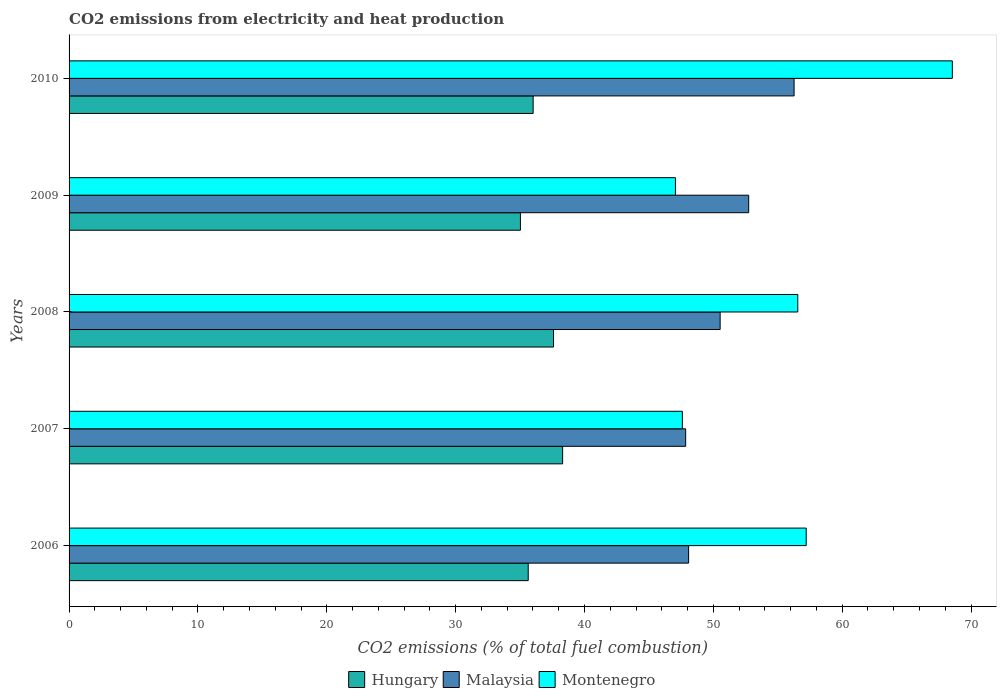How many different coloured bars are there?
Make the answer very short. 3. How many groups of bars are there?
Make the answer very short. 5. In how many cases, is the number of bars for a given year not equal to the number of legend labels?
Give a very brief answer. 0. What is the amount of CO2 emitted in Malaysia in 2010?
Ensure brevity in your answer.  56.27. Across all years, what is the maximum amount of CO2 emitted in Hungary?
Make the answer very short. 38.3. Across all years, what is the minimum amount of CO2 emitted in Hungary?
Your answer should be compact. 35.03. What is the total amount of CO2 emitted in Malaysia in the graph?
Your answer should be very brief. 255.48. What is the difference between the amount of CO2 emitted in Malaysia in 2006 and that in 2007?
Your answer should be very brief. 0.23. What is the difference between the amount of CO2 emitted in Malaysia in 2010 and the amount of CO2 emitted in Hungary in 2009?
Provide a succinct answer. 21.24. What is the average amount of CO2 emitted in Montenegro per year?
Provide a succinct answer. 55.39. In the year 2009, what is the difference between the amount of CO2 emitted in Montenegro and amount of CO2 emitted in Malaysia?
Offer a terse response. -5.69. In how many years, is the amount of CO2 emitted in Malaysia greater than 66 %?
Give a very brief answer. 0. What is the ratio of the amount of CO2 emitted in Malaysia in 2009 to that in 2010?
Your answer should be very brief. 0.94. Is the amount of CO2 emitted in Malaysia in 2008 less than that in 2010?
Make the answer very short. Yes. What is the difference between the highest and the second highest amount of CO2 emitted in Montenegro?
Ensure brevity in your answer.  11.34. What is the difference between the highest and the lowest amount of CO2 emitted in Montenegro?
Your answer should be compact. 21.49. In how many years, is the amount of CO2 emitted in Hungary greater than the average amount of CO2 emitted in Hungary taken over all years?
Your answer should be compact. 2. Is the sum of the amount of CO2 emitted in Montenegro in 2006 and 2008 greater than the maximum amount of CO2 emitted in Malaysia across all years?
Provide a short and direct response. Yes. What does the 2nd bar from the top in 2010 represents?
Make the answer very short. Malaysia. What does the 2nd bar from the bottom in 2008 represents?
Offer a terse response. Malaysia. How many bars are there?
Make the answer very short. 15. Are all the bars in the graph horizontal?
Your answer should be very brief. Yes. What is the difference between two consecutive major ticks on the X-axis?
Your answer should be very brief. 10. How are the legend labels stacked?
Your answer should be very brief. Horizontal. What is the title of the graph?
Your answer should be compact. CO2 emissions from electricity and heat production. What is the label or title of the X-axis?
Your answer should be very brief. CO2 emissions (% of total fuel combustion). What is the CO2 emissions (% of total fuel combustion) in Hungary in 2006?
Offer a terse response. 35.63. What is the CO2 emissions (% of total fuel combustion) in Malaysia in 2006?
Offer a very short reply. 48.08. What is the CO2 emissions (% of total fuel combustion) of Montenegro in 2006?
Offer a terse response. 57.21. What is the CO2 emissions (% of total fuel combustion) in Hungary in 2007?
Keep it short and to the point. 38.3. What is the CO2 emissions (% of total fuel combustion) in Malaysia in 2007?
Your response must be concise. 47.85. What is the CO2 emissions (% of total fuel combustion) in Montenegro in 2007?
Your response must be concise. 47.6. What is the CO2 emissions (% of total fuel combustion) in Hungary in 2008?
Keep it short and to the point. 37.6. What is the CO2 emissions (% of total fuel combustion) in Malaysia in 2008?
Ensure brevity in your answer.  50.53. What is the CO2 emissions (% of total fuel combustion) of Montenegro in 2008?
Give a very brief answer. 56.55. What is the CO2 emissions (% of total fuel combustion) of Hungary in 2009?
Make the answer very short. 35.03. What is the CO2 emissions (% of total fuel combustion) of Malaysia in 2009?
Make the answer very short. 52.75. What is the CO2 emissions (% of total fuel combustion) of Montenegro in 2009?
Give a very brief answer. 47.06. What is the CO2 emissions (% of total fuel combustion) of Hungary in 2010?
Provide a succinct answer. 36.02. What is the CO2 emissions (% of total fuel combustion) in Malaysia in 2010?
Provide a short and direct response. 56.27. What is the CO2 emissions (% of total fuel combustion) in Montenegro in 2010?
Offer a very short reply. 68.55. Across all years, what is the maximum CO2 emissions (% of total fuel combustion) of Hungary?
Keep it short and to the point. 38.3. Across all years, what is the maximum CO2 emissions (% of total fuel combustion) in Malaysia?
Provide a short and direct response. 56.27. Across all years, what is the maximum CO2 emissions (% of total fuel combustion) in Montenegro?
Give a very brief answer. 68.55. Across all years, what is the minimum CO2 emissions (% of total fuel combustion) in Hungary?
Your answer should be compact. 35.03. Across all years, what is the minimum CO2 emissions (% of total fuel combustion) in Malaysia?
Keep it short and to the point. 47.85. Across all years, what is the minimum CO2 emissions (% of total fuel combustion) of Montenegro?
Your answer should be compact. 47.06. What is the total CO2 emissions (% of total fuel combustion) in Hungary in the graph?
Provide a succinct answer. 182.58. What is the total CO2 emissions (% of total fuel combustion) in Malaysia in the graph?
Keep it short and to the point. 255.48. What is the total CO2 emissions (% of total fuel combustion) of Montenegro in the graph?
Offer a very short reply. 276.96. What is the difference between the CO2 emissions (% of total fuel combustion) in Hungary in 2006 and that in 2007?
Offer a terse response. -2.67. What is the difference between the CO2 emissions (% of total fuel combustion) of Malaysia in 2006 and that in 2007?
Ensure brevity in your answer.  0.23. What is the difference between the CO2 emissions (% of total fuel combustion) of Montenegro in 2006 and that in 2007?
Provide a succinct answer. 9.61. What is the difference between the CO2 emissions (% of total fuel combustion) of Hungary in 2006 and that in 2008?
Your response must be concise. -1.96. What is the difference between the CO2 emissions (% of total fuel combustion) of Malaysia in 2006 and that in 2008?
Provide a short and direct response. -2.45. What is the difference between the CO2 emissions (% of total fuel combustion) of Montenegro in 2006 and that in 2008?
Keep it short and to the point. 0.65. What is the difference between the CO2 emissions (% of total fuel combustion) in Hungary in 2006 and that in 2009?
Your response must be concise. 0.6. What is the difference between the CO2 emissions (% of total fuel combustion) in Malaysia in 2006 and that in 2009?
Your response must be concise. -4.66. What is the difference between the CO2 emissions (% of total fuel combustion) of Montenegro in 2006 and that in 2009?
Offer a terse response. 10.15. What is the difference between the CO2 emissions (% of total fuel combustion) in Hungary in 2006 and that in 2010?
Ensure brevity in your answer.  -0.38. What is the difference between the CO2 emissions (% of total fuel combustion) of Malaysia in 2006 and that in 2010?
Provide a succinct answer. -8.19. What is the difference between the CO2 emissions (% of total fuel combustion) in Montenegro in 2006 and that in 2010?
Keep it short and to the point. -11.34. What is the difference between the CO2 emissions (% of total fuel combustion) in Hungary in 2007 and that in 2008?
Provide a succinct answer. 0.71. What is the difference between the CO2 emissions (% of total fuel combustion) in Malaysia in 2007 and that in 2008?
Make the answer very short. -2.68. What is the difference between the CO2 emissions (% of total fuel combustion) in Montenegro in 2007 and that in 2008?
Provide a succinct answer. -8.96. What is the difference between the CO2 emissions (% of total fuel combustion) of Hungary in 2007 and that in 2009?
Provide a short and direct response. 3.27. What is the difference between the CO2 emissions (% of total fuel combustion) in Malaysia in 2007 and that in 2009?
Your answer should be compact. -4.89. What is the difference between the CO2 emissions (% of total fuel combustion) in Montenegro in 2007 and that in 2009?
Make the answer very short. 0.54. What is the difference between the CO2 emissions (% of total fuel combustion) of Hungary in 2007 and that in 2010?
Provide a succinct answer. 2.29. What is the difference between the CO2 emissions (% of total fuel combustion) in Malaysia in 2007 and that in 2010?
Offer a terse response. -8.42. What is the difference between the CO2 emissions (% of total fuel combustion) of Montenegro in 2007 and that in 2010?
Your response must be concise. -20.95. What is the difference between the CO2 emissions (% of total fuel combustion) in Hungary in 2008 and that in 2009?
Make the answer very short. 2.57. What is the difference between the CO2 emissions (% of total fuel combustion) in Malaysia in 2008 and that in 2009?
Your answer should be compact. -2.22. What is the difference between the CO2 emissions (% of total fuel combustion) in Montenegro in 2008 and that in 2009?
Give a very brief answer. 9.5. What is the difference between the CO2 emissions (% of total fuel combustion) of Hungary in 2008 and that in 2010?
Ensure brevity in your answer.  1.58. What is the difference between the CO2 emissions (% of total fuel combustion) in Malaysia in 2008 and that in 2010?
Ensure brevity in your answer.  -5.74. What is the difference between the CO2 emissions (% of total fuel combustion) in Montenegro in 2008 and that in 2010?
Provide a short and direct response. -11.99. What is the difference between the CO2 emissions (% of total fuel combustion) of Hungary in 2009 and that in 2010?
Keep it short and to the point. -0.99. What is the difference between the CO2 emissions (% of total fuel combustion) of Malaysia in 2009 and that in 2010?
Provide a short and direct response. -3.52. What is the difference between the CO2 emissions (% of total fuel combustion) in Montenegro in 2009 and that in 2010?
Provide a succinct answer. -21.49. What is the difference between the CO2 emissions (% of total fuel combustion) in Hungary in 2006 and the CO2 emissions (% of total fuel combustion) in Malaysia in 2007?
Your response must be concise. -12.22. What is the difference between the CO2 emissions (% of total fuel combustion) in Hungary in 2006 and the CO2 emissions (% of total fuel combustion) in Montenegro in 2007?
Your answer should be very brief. -11.96. What is the difference between the CO2 emissions (% of total fuel combustion) of Malaysia in 2006 and the CO2 emissions (% of total fuel combustion) of Montenegro in 2007?
Make the answer very short. 0.49. What is the difference between the CO2 emissions (% of total fuel combustion) in Hungary in 2006 and the CO2 emissions (% of total fuel combustion) in Malaysia in 2008?
Your answer should be compact. -14.89. What is the difference between the CO2 emissions (% of total fuel combustion) in Hungary in 2006 and the CO2 emissions (% of total fuel combustion) in Montenegro in 2008?
Offer a terse response. -20.92. What is the difference between the CO2 emissions (% of total fuel combustion) in Malaysia in 2006 and the CO2 emissions (% of total fuel combustion) in Montenegro in 2008?
Provide a succinct answer. -8.47. What is the difference between the CO2 emissions (% of total fuel combustion) of Hungary in 2006 and the CO2 emissions (% of total fuel combustion) of Malaysia in 2009?
Your answer should be compact. -17.11. What is the difference between the CO2 emissions (% of total fuel combustion) in Hungary in 2006 and the CO2 emissions (% of total fuel combustion) in Montenegro in 2009?
Offer a terse response. -11.43. What is the difference between the CO2 emissions (% of total fuel combustion) in Malaysia in 2006 and the CO2 emissions (% of total fuel combustion) in Montenegro in 2009?
Give a very brief answer. 1.02. What is the difference between the CO2 emissions (% of total fuel combustion) in Hungary in 2006 and the CO2 emissions (% of total fuel combustion) in Malaysia in 2010?
Offer a terse response. -20.64. What is the difference between the CO2 emissions (% of total fuel combustion) of Hungary in 2006 and the CO2 emissions (% of total fuel combustion) of Montenegro in 2010?
Give a very brief answer. -32.91. What is the difference between the CO2 emissions (% of total fuel combustion) in Malaysia in 2006 and the CO2 emissions (% of total fuel combustion) in Montenegro in 2010?
Give a very brief answer. -20.47. What is the difference between the CO2 emissions (% of total fuel combustion) in Hungary in 2007 and the CO2 emissions (% of total fuel combustion) in Malaysia in 2008?
Offer a very short reply. -12.22. What is the difference between the CO2 emissions (% of total fuel combustion) of Hungary in 2007 and the CO2 emissions (% of total fuel combustion) of Montenegro in 2008?
Keep it short and to the point. -18.25. What is the difference between the CO2 emissions (% of total fuel combustion) in Malaysia in 2007 and the CO2 emissions (% of total fuel combustion) in Montenegro in 2008?
Offer a very short reply. -8.7. What is the difference between the CO2 emissions (% of total fuel combustion) of Hungary in 2007 and the CO2 emissions (% of total fuel combustion) of Malaysia in 2009?
Your response must be concise. -14.44. What is the difference between the CO2 emissions (% of total fuel combustion) of Hungary in 2007 and the CO2 emissions (% of total fuel combustion) of Montenegro in 2009?
Give a very brief answer. -8.76. What is the difference between the CO2 emissions (% of total fuel combustion) in Malaysia in 2007 and the CO2 emissions (% of total fuel combustion) in Montenegro in 2009?
Make the answer very short. 0.79. What is the difference between the CO2 emissions (% of total fuel combustion) of Hungary in 2007 and the CO2 emissions (% of total fuel combustion) of Malaysia in 2010?
Your answer should be very brief. -17.96. What is the difference between the CO2 emissions (% of total fuel combustion) in Hungary in 2007 and the CO2 emissions (% of total fuel combustion) in Montenegro in 2010?
Your response must be concise. -30.24. What is the difference between the CO2 emissions (% of total fuel combustion) of Malaysia in 2007 and the CO2 emissions (% of total fuel combustion) of Montenegro in 2010?
Make the answer very short. -20.7. What is the difference between the CO2 emissions (% of total fuel combustion) in Hungary in 2008 and the CO2 emissions (% of total fuel combustion) in Malaysia in 2009?
Provide a short and direct response. -15.15. What is the difference between the CO2 emissions (% of total fuel combustion) in Hungary in 2008 and the CO2 emissions (% of total fuel combustion) in Montenegro in 2009?
Ensure brevity in your answer.  -9.46. What is the difference between the CO2 emissions (% of total fuel combustion) of Malaysia in 2008 and the CO2 emissions (% of total fuel combustion) of Montenegro in 2009?
Keep it short and to the point. 3.47. What is the difference between the CO2 emissions (% of total fuel combustion) of Hungary in 2008 and the CO2 emissions (% of total fuel combustion) of Malaysia in 2010?
Your answer should be compact. -18.67. What is the difference between the CO2 emissions (% of total fuel combustion) in Hungary in 2008 and the CO2 emissions (% of total fuel combustion) in Montenegro in 2010?
Give a very brief answer. -30.95. What is the difference between the CO2 emissions (% of total fuel combustion) of Malaysia in 2008 and the CO2 emissions (% of total fuel combustion) of Montenegro in 2010?
Provide a succinct answer. -18.02. What is the difference between the CO2 emissions (% of total fuel combustion) of Hungary in 2009 and the CO2 emissions (% of total fuel combustion) of Malaysia in 2010?
Keep it short and to the point. -21.24. What is the difference between the CO2 emissions (% of total fuel combustion) of Hungary in 2009 and the CO2 emissions (% of total fuel combustion) of Montenegro in 2010?
Keep it short and to the point. -33.52. What is the difference between the CO2 emissions (% of total fuel combustion) of Malaysia in 2009 and the CO2 emissions (% of total fuel combustion) of Montenegro in 2010?
Ensure brevity in your answer.  -15.8. What is the average CO2 emissions (% of total fuel combustion) in Hungary per year?
Your answer should be very brief. 36.52. What is the average CO2 emissions (% of total fuel combustion) of Malaysia per year?
Provide a short and direct response. 51.1. What is the average CO2 emissions (% of total fuel combustion) in Montenegro per year?
Ensure brevity in your answer.  55.39. In the year 2006, what is the difference between the CO2 emissions (% of total fuel combustion) of Hungary and CO2 emissions (% of total fuel combustion) of Malaysia?
Your response must be concise. -12.45. In the year 2006, what is the difference between the CO2 emissions (% of total fuel combustion) in Hungary and CO2 emissions (% of total fuel combustion) in Montenegro?
Offer a very short reply. -21.57. In the year 2006, what is the difference between the CO2 emissions (% of total fuel combustion) in Malaysia and CO2 emissions (% of total fuel combustion) in Montenegro?
Your answer should be compact. -9.13. In the year 2007, what is the difference between the CO2 emissions (% of total fuel combustion) in Hungary and CO2 emissions (% of total fuel combustion) in Malaysia?
Your response must be concise. -9.55. In the year 2007, what is the difference between the CO2 emissions (% of total fuel combustion) of Hungary and CO2 emissions (% of total fuel combustion) of Montenegro?
Your response must be concise. -9.29. In the year 2007, what is the difference between the CO2 emissions (% of total fuel combustion) of Malaysia and CO2 emissions (% of total fuel combustion) of Montenegro?
Ensure brevity in your answer.  0.26. In the year 2008, what is the difference between the CO2 emissions (% of total fuel combustion) in Hungary and CO2 emissions (% of total fuel combustion) in Malaysia?
Keep it short and to the point. -12.93. In the year 2008, what is the difference between the CO2 emissions (% of total fuel combustion) in Hungary and CO2 emissions (% of total fuel combustion) in Montenegro?
Your response must be concise. -18.96. In the year 2008, what is the difference between the CO2 emissions (% of total fuel combustion) in Malaysia and CO2 emissions (% of total fuel combustion) in Montenegro?
Your response must be concise. -6.03. In the year 2009, what is the difference between the CO2 emissions (% of total fuel combustion) in Hungary and CO2 emissions (% of total fuel combustion) in Malaysia?
Give a very brief answer. -17.72. In the year 2009, what is the difference between the CO2 emissions (% of total fuel combustion) in Hungary and CO2 emissions (% of total fuel combustion) in Montenegro?
Give a very brief answer. -12.03. In the year 2009, what is the difference between the CO2 emissions (% of total fuel combustion) in Malaysia and CO2 emissions (% of total fuel combustion) in Montenegro?
Your response must be concise. 5.69. In the year 2010, what is the difference between the CO2 emissions (% of total fuel combustion) of Hungary and CO2 emissions (% of total fuel combustion) of Malaysia?
Give a very brief answer. -20.25. In the year 2010, what is the difference between the CO2 emissions (% of total fuel combustion) in Hungary and CO2 emissions (% of total fuel combustion) in Montenegro?
Offer a terse response. -32.53. In the year 2010, what is the difference between the CO2 emissions (% of total fuel combustion) of Malaysia and CO2 emissions (% of total fuel combustion) of Montenegro?
Keep it short and to the point. -12.28. What is the ratio of the CO2 emissions (% of total fuel combustion) in Hungary in 2006 to that in 2007?
Your answer should be compact. 0.93. What is the ratio of the CO2 emissions (% of total fuel combustion) in Malaysia in 2006 to that in 2007?
Offer a terse response. 1. What is the ratio of the CO2 emissions (% of total fuel combustion) in Montenegro in 2006 to that in 2007?
Provide a short and direct response. 1.2. What is the ratio of the CO2 emissions (% of total fuel combustion) in Hungary in 2006 to that in 2008?
Offer a terse response. 0.95. What is the ratio of the CO2 emissions (% of total fuel combustion) in Malaysia in 2006 to that in 2008?
Offer a very short reply. 0.95. What is the ratio of the CO2 emissions (% of total fuel combustion) of Montenegro in 2006 to that in 2008?
Your answer should be very brief. 1.01. What is the ratio of the CO2 emissions (% of total fuel combustion) in Hungary in 2006 to that in 2009?
Offer a very short reply. 1.02. What is the ratio of the CO2 emissions (% of total fuel combustion) of Malaysia in 2006 to that in 2009?
Keep it short and to the point. 0.91. What is the ratio of the CO2 emissions (% of total fuel combustion) in Montenegro in 2006 to that in 2009?
Make the answer very short. 1.22. What is the ratio of the CO2 emissions (% of total fuel combustion) in Malaysia in 2006 to that in 2010?
Your answer should be compact. 0.85. What is the ratio of the CO2 emissions (% of total fuel combustion) of Montenegro in 2006 to that in 2010?
Offer a very short reply. 0.83. What is the ratio of the CO2 emissions (% of total fuel combustion) in Hungary in 2007 to that in 2008?
Provide a short and direct response. 1.02. What is the ratio of the CO2 emissions (% of total fuel combustion) of Malaysia in 2007 to that in 2008?
Offer a very short reply. 0.95. What is the ratio of the CO2 emissions (% of total fuel combustion) of Montenegro in 2007 to that in 2008?
Your answer should be compact. 0.84. What is the ratio of the CO2 emissions (% of total fuel combustion) of Hungary in 2007 to that in 2009?
Your answer should be compact. 1.09. What is the ratio of the CO2 emissions (% of total fuel combustion) of Malaysia in 2007 to that in 2009?
Offer a very short reply. 0.91. What is the ratio of the CO2 emissions (% of total fuel combustion) of Montenegro in 2007 to that in 2009?
Your answer should be very brief. 1.01. What is the ratio of the CO2 emissions (% of total fuel combustion) of Hungary in 2007 to that in 2010?
Your response must be concise. 1.06. What is the ratio of the CO2 emissions (% of total fuel combustion) of Malaysia in 2007 to that in 2010?
Your answer should be very brief. 0.85. What is the ratio of the CO2 emissions (% of total fuel combustion) of Montenegro in 2007 to that in 2010?
Offer a terse response. 0.69. What is the ratio of the CO2 emissions (% of total fuel combustion) of Hungary in 2008 to that in 2009?
Your answer should be compact. 1.07. What is the ratio of the CO2 emissions (% of total fuel combustion) in Malaysia in 2008 to that in 2009?
Your response must be concise. 0.96. What is the ratio of the CO2 emissions (% of total fuel combustion) in Montenegro in 2008 to that in 2009?
Make the answer very short. 1.2. What is the ratio of the CO2 emissions (% of total fuel combustion) of Hungary in 2008 to that in 2010?
Provide a short and direct response. 1.04. What is the ratio of the CO2 emissions (% of total fuel combustion) of Malaysia in 2008 to that in 2010?
Offer a very short reply. 0.9. What is the ratio of the CO2 emissions (% of total fuel combustion) of Montenegro in 2008 to that in 2010?
Offer a very short reply. 0.82. What is the ratio of the CO2 emissions (% of total fuel combustion) in Hungary in 2009 to that in 2010?
Your answer should be compact. 0.97. What is the ratio of the CO2 emissions (% of total fuel combustion) of Malaysia in 2009 to that in 2010?
Keep it short and to the point. 0.94. What is the ratio of the CO2 emissions (% of total fuel combustion) in Montenegro in 2009 to that in 2010?
Your answer should be compact. 0.69. What is the difference between the highest and the second highest CO2 emissions (% of total fuel combustion) in Hungary?
Make the answer very short. 0.71. What is the difference between the highest and the second highest CO2 emissions (% of total fuel combustion) in Malaysia?
Provide a short and direct response. 3.52. What is the difference between the highest and the second highest CO2 emissions (% of total fuel combustion) of Montenegro?
Ensure brevity in your answer.  11.34. What is the difference between the highest and the lowest CO2 emissions (% of total fuel combustion) of Hungary?
Keep it short and to the point. 3.27. What is the difference between the highest and the lowest CO2 emissions (% of total fuel combustion) in Malaysia?
Offer a very short reply. 8.42. What is the difference between the highest and the lowest CO2 emissions (% of total fuel combustion) in Montenegro?
Provide a short and direct response. 21.49. 